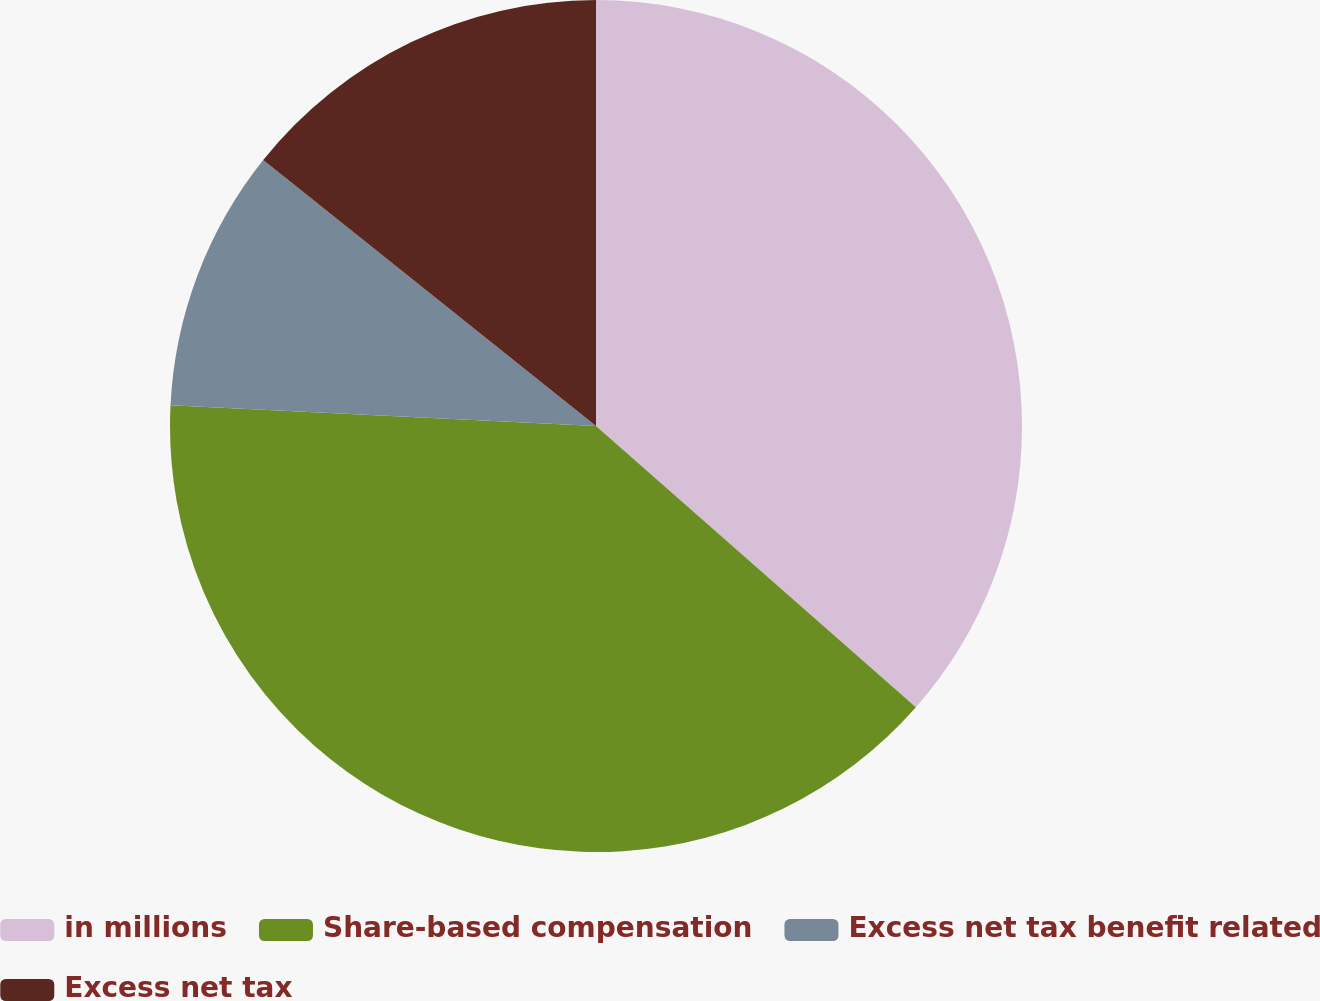<chart> <loc_0><loc_0><loc_500><loc_500><pie_chart><fcel>in millions<fcel>Share-based compensation<fcel>Excess net tax benefit related<fcel>Excess net tax<nl><fcel>36.48%<fcel>39.3%<fcel>9.95%<fcel>14.27%<nl></chart> 